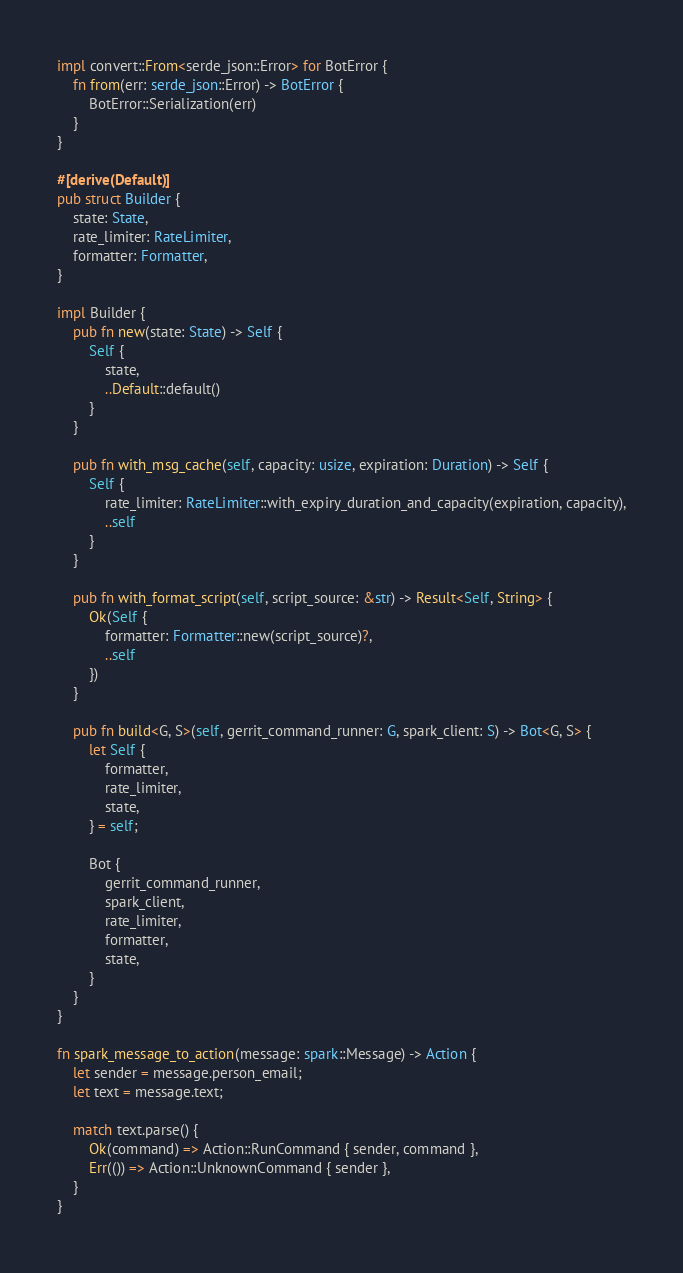<code> <loc_0><loc_0><loc_500><loc_500><_Rust_>impl convert::From<serde_json::Error> for BotError {
    fn from(err: serde_json::Error) -> BotError {
        BotError::Serialization(err)
    }
}

#[derive(Default)]
pub struct Builder {
    state: State,
    rate_limiter: RateLimiter,
    formatter: Formatter,
}

impl Builder {
    pub fn new(state: State) -> Self {
        Self {
            state,
            ..Default::default()
        }
    }

    pub fn with_msg_cache(self, capacity: usize, expiration: Duration) -> Self {
        Self {
            rate_limiter: RateLimiter::with_expiry_duration_and_capacity(expiration, capacity),
            ..self
        }
    }

    pub fn with_format_script(self, script_source: &str) -> Result<Self, String> {
        Ok(Self {
            formatter: Formatter::new(script_source)?,
            ..self
        })
    }

    pub fn build<G, S>(self, gerrit_command_runner: G, spark_client: S) -> Bot<G, S> {
        let Self {
            formatter,
            rate_limiter,
            state,
        } = self;

        Bot {
            gerrit_command_runner,
            spark_client,
            rate_limiter,
            formatter,
            state,
        }
    }
}

fn spark_message_to_action(message: spark::Message) -> Action {
    let sender = message.person_email;
    let text = message.text;

    match text.parse() {
        Ok(command) => Action::RunCommand { sender, command },
        Err(()) => Action::UnknownCommand { sender },
    }
}
</code> 